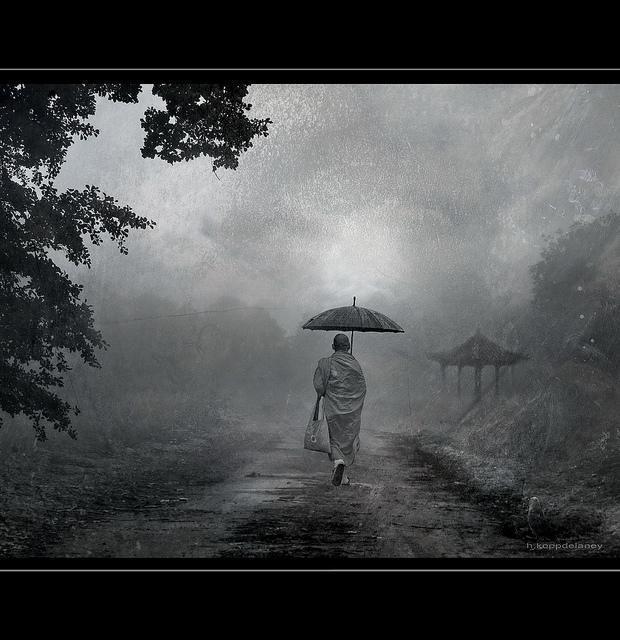How many forks are there?
Give a very brief answer. 0. 